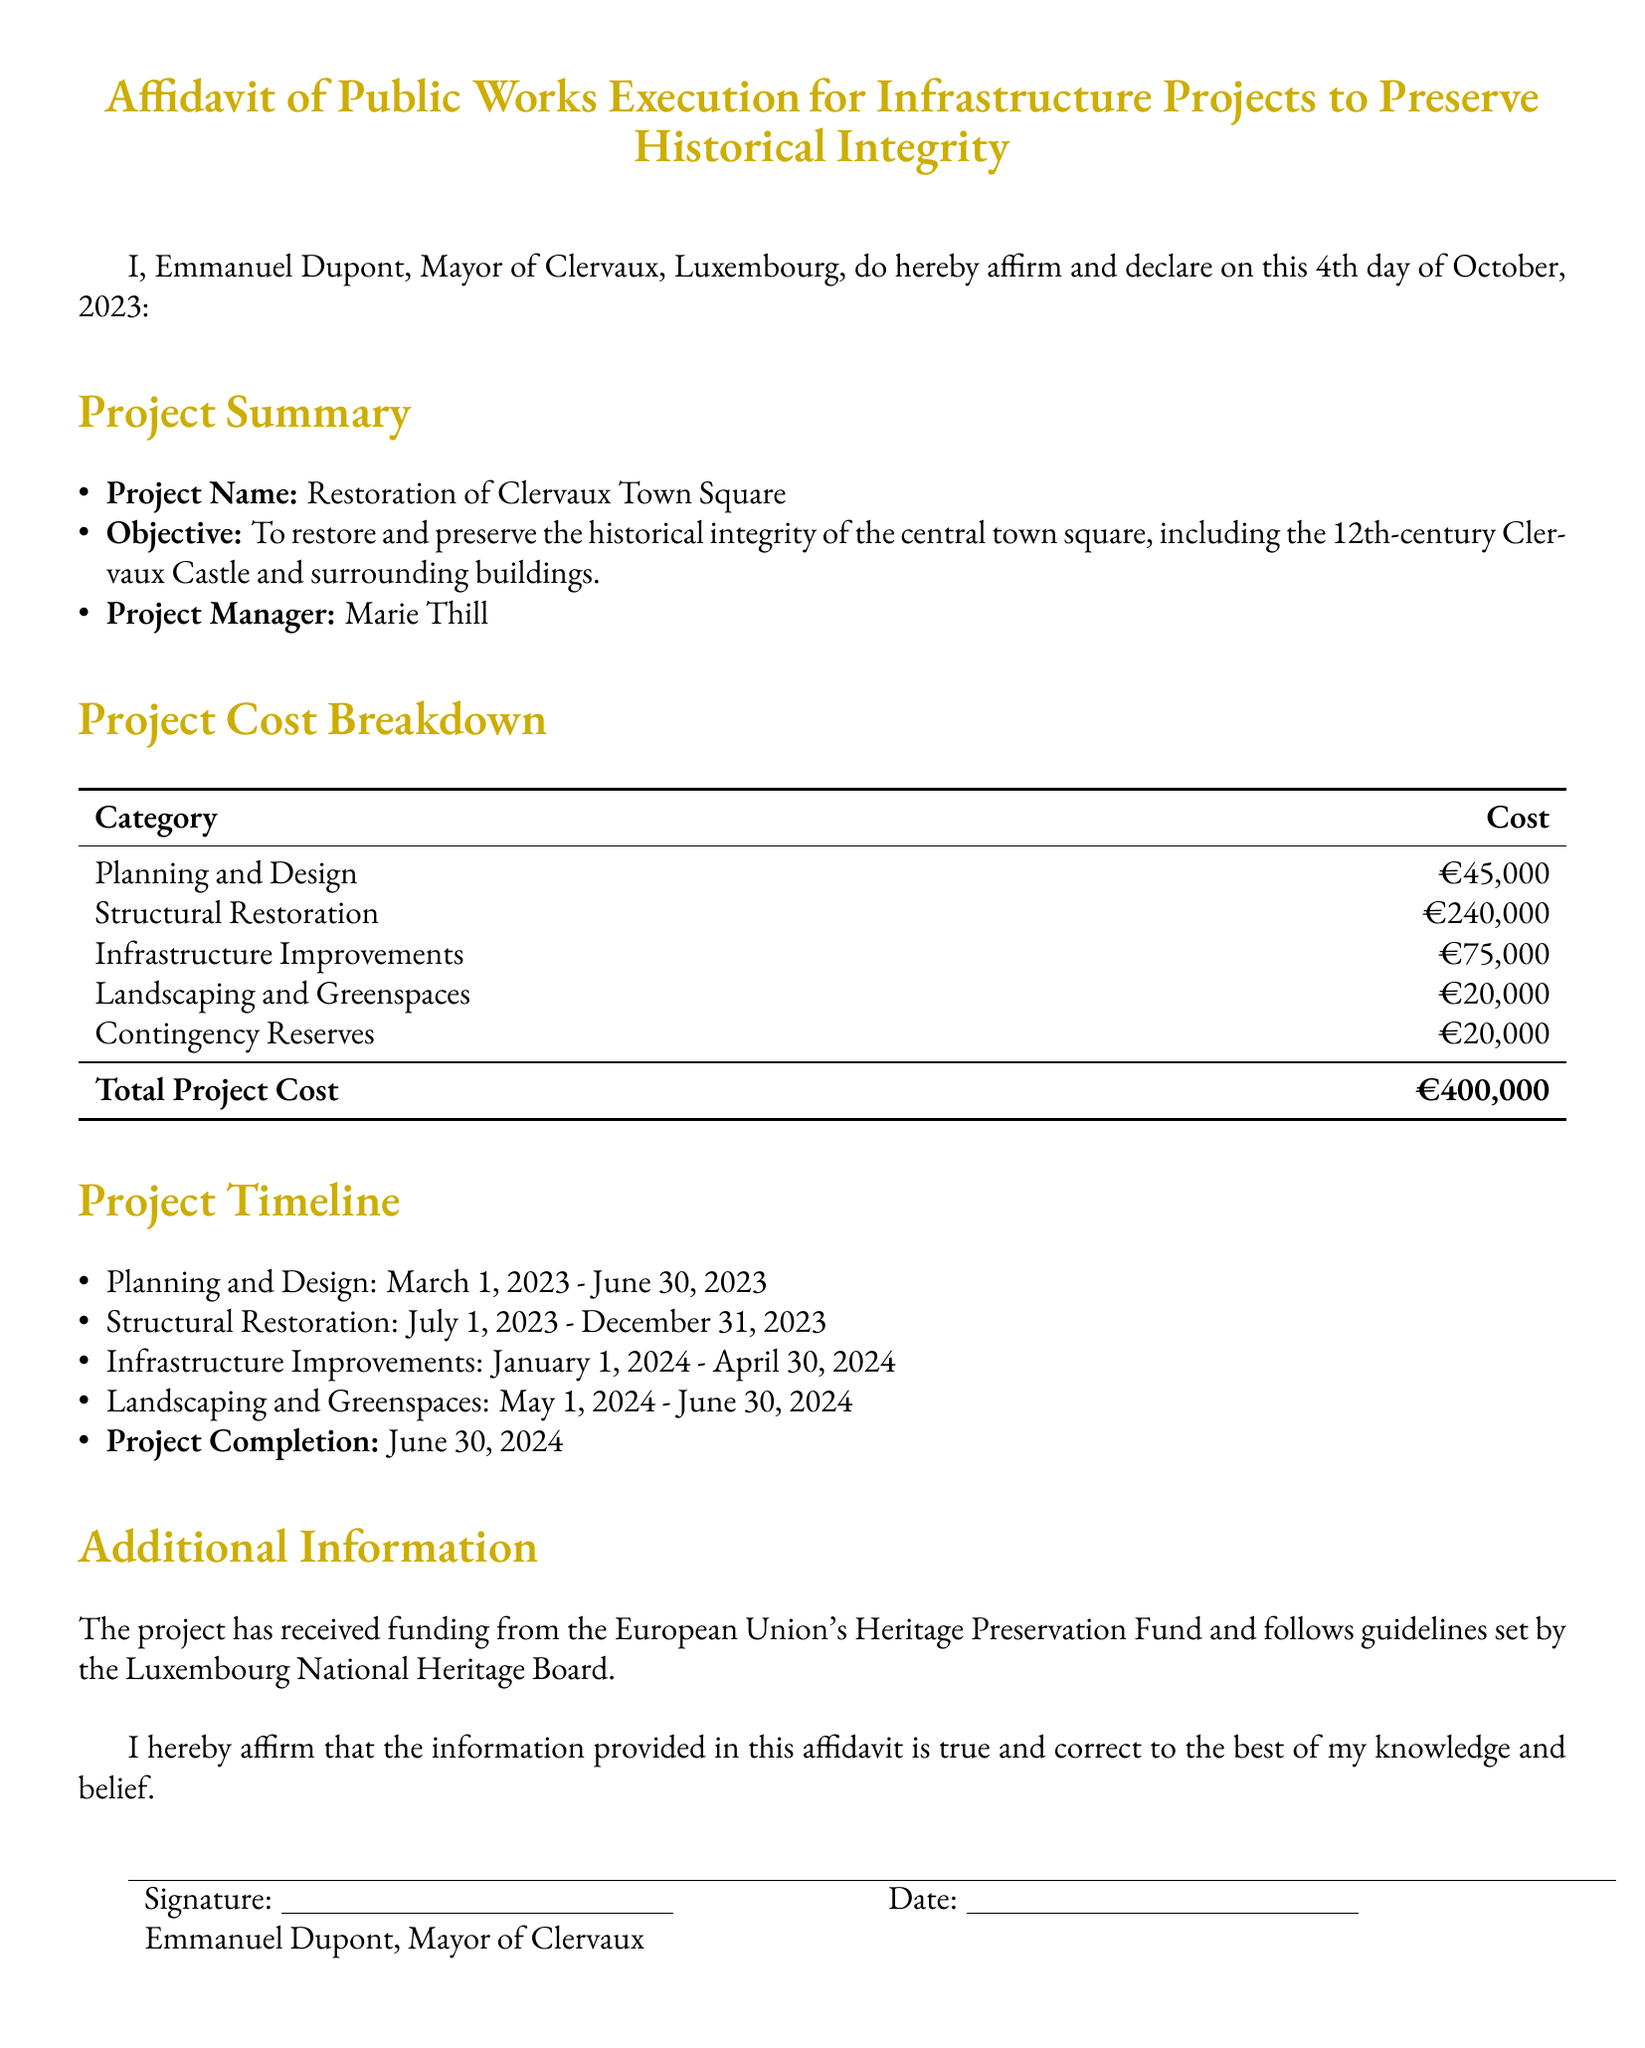What is the project name? The project name is explicitly stated in the document under the project summary section.
Answer: Restoration of Clervaux Town Square Who is the project manager? The project manager's name is included in the project summary section of the affidavit.
Answer: Marie Thill What is the total project cost? The total project cost is summarized in the cost breakdown table at the end of that section.
Answer: €400,000 What is the timeline for the structural restoration phase? The document specifies the timeline for each phase, including structural restoration, within the project timeline section.
Answer: July 1, 2023 - December 31, 2023 How much is allocated for contingency reserves? The amount allocated for contingency reserves is detailed in the project cost breakdown table.
Answer: €20,000 What is the funding source for the project? The document mentions the source of funding in the additional information section.
Answer: European Union's Heritage Preservation Fund When is the expected project completion date? The expected project completion date is explicitly stated in the project timeline section.
Answer: June 30, 2024 What percentage of the total cost is allocated to structural restoration? To find this, calculate the ratio of structural restoration cost to total project cost as mentioned in the cost breakdown.
Answer: 60% What is one of the historical landmarks included in the project? The document highlights the historical landmark within the project objective.
Answer: Clervaux Castle 